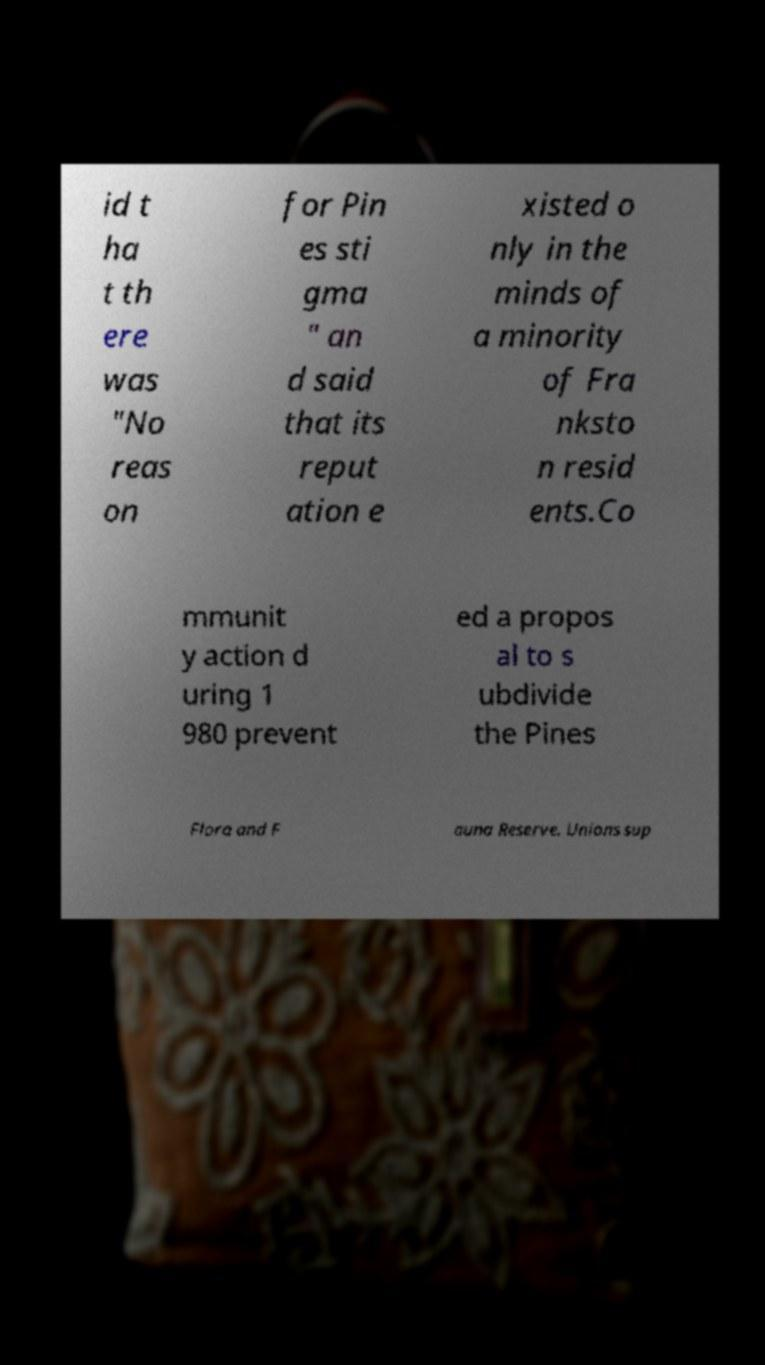Can you accurately transcribe the text from the provided image for me? id t ha t th ere was "No reas on for Pin es sti gma " an d said that its reput ation e xisted o nly in the minds of a minority of Fra nksto n resid ents.Co mmunit y action d uring 1 980 prevent ed a propos al to s ubdivide the Pines Flora and F auna Reserve. Unions sup 